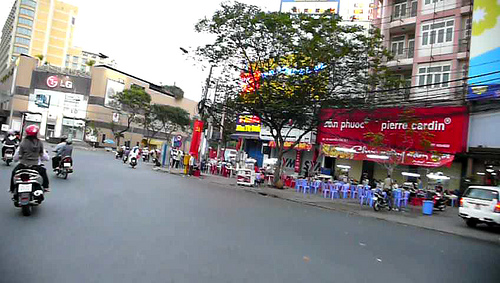Which side is the girl on? The girl in the image is located on the left side. 